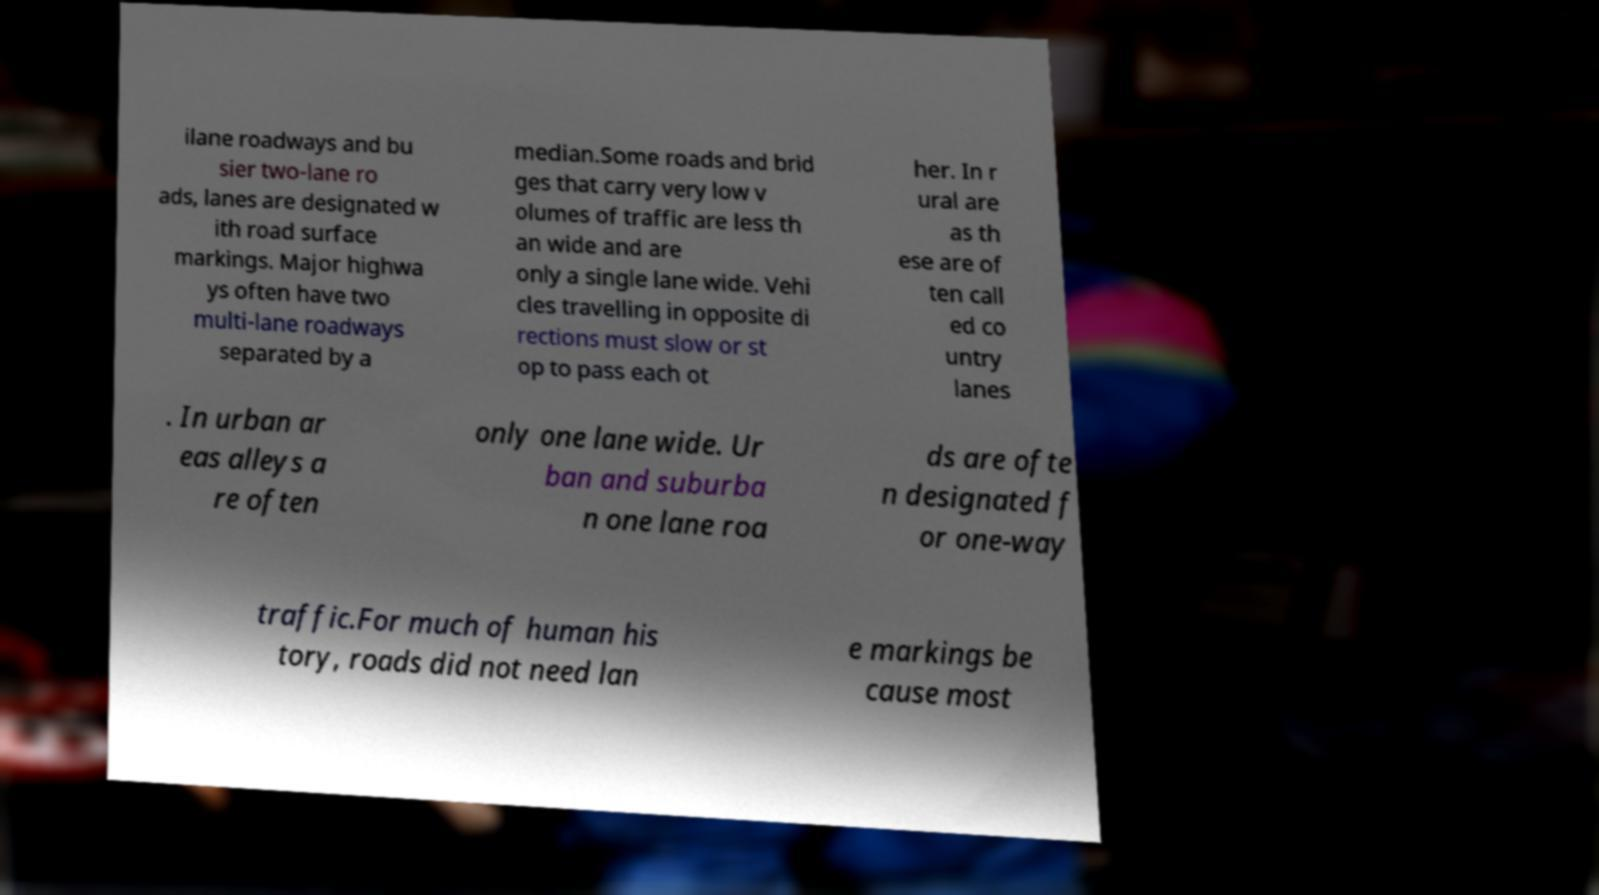Please read and relay the text visible in this image. What does it say? ilane roadways and bu sier two-lane ro ads, lanes are designated w ith road surface markings. Major highwa ys often have two multi-lane roadways separated by a median.Some roads and brid ges that carry very low v olumes of traffic are less th an wide and are only a single lane wide. Vehi cles travelling in opposite di rections must slow or st op to pass each ot her. In r ural are as th ese are of ten call ed co untry lanes . In urban ar eas alleys a re often only one lane wide. Ur ban and suburba n one lane roa ds are ofte n designated f or one-way traffic.For much of human his tory, roads did not need lan e markings be cause most 